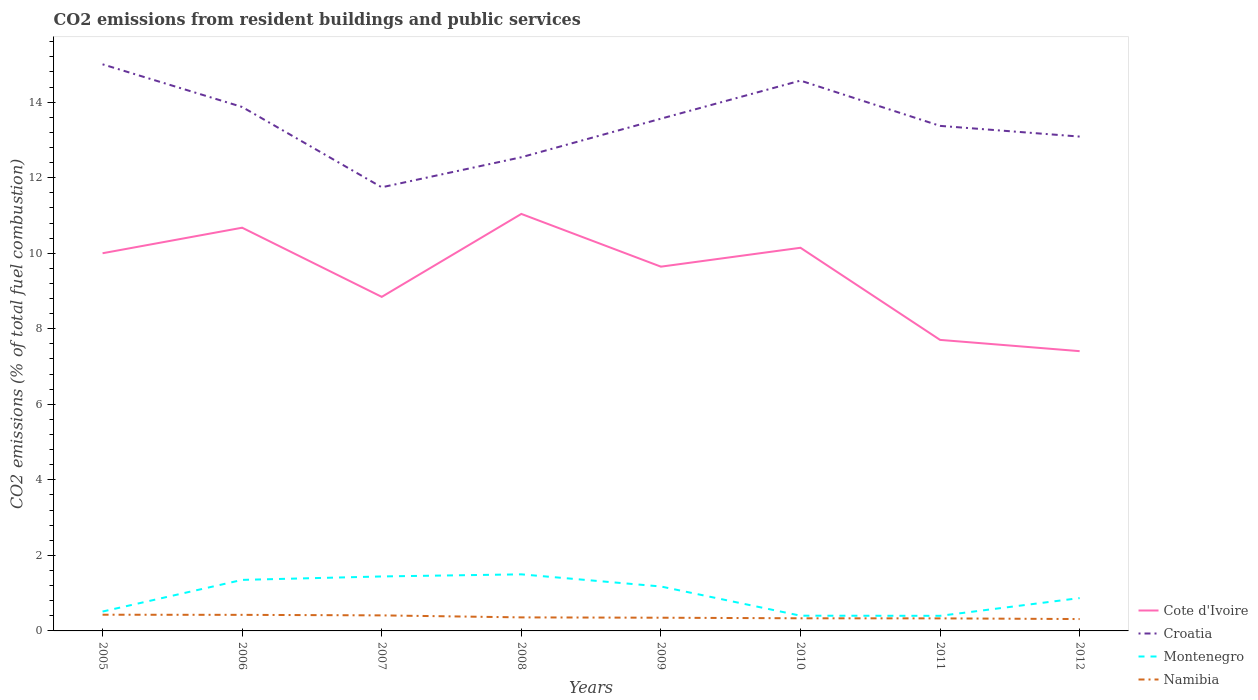Across all years, what is the maximum total CO2 emitted in Namibia?
Provide a short and direct response. 0.31. What is the total total CO2 emitted in Namibia in the graph?
Offer a very short reply. 0.08. What is the difference between the highest and the second highest total CO2 emitted in Montenegro?
Give a very brief answer. 1.1. What is the difference between the highest and the lowest total CO2 emitted in Montenegro?
Provide a short and direct response. 4. Is the total CO2 emitted in Montenegro strictly greater than the total CO2 emitted in Croatia over the years?
Make the answer very short. Yes. What is the difference between two consecutive major ticks on the Y-axis?
Your response must be concise. 2. Does the graph contain any zero values?
Give a very brief answer. No. Does the graph contain grids?
Provide a short and direct response. No. How many legend labels are there?
Keep it short and to the point. 4. How are the legend labels stacked?
Offer a terse response. Vertical. What is the title of the graph?
Provide a short and direct response. CO2 emissions from resident buildings and public services. What is the label or title of the X-axis?
Keep it short and to the point. Years. What is the label or title of the Y-axis?
Provide a short and direct response. CO2 emissions (% of total fuel combustion). What is the CO2 emissions (% of total fuel combustion) in Croatia in 2005?
Your answer should be compact. 15. What is the CO2 emissions (% of total fuel combustion) in Montenegro in 2005?
Keep it short and to the point. 0.51. What is the CO2 emissions (% of total fuel combustion) of Namibia in 2005?
Offer a very short reply. 0.43. What is the CO2 emissions (% of total fuel combustion) in Cote d'Ivoire in 2006?
Offer a terse response. 10.68. What is the CO2 emissions (% of total fuel combustion) in Croatia in 2006?
Provide a succinct answer. 13.87. What is the CO2 emissions (% of total fuel combustion) in Montenegro in 2006?
Make the answer very short. 1.35. What is the CO2 emissions (% of total fuel combustion) of Namibia in 2006?
Offer a very short reply. 0.43. What is the CO2 emissions (% of total fuel combustion) of Cote d'Ivoire in 2007?
Offer a terse response. 8.84. What is the CO2 emissions (% of total fuel combustion) in Croatia in 2007?
Provide a short and direct response. 11.75. What is the CO2 emissions (% of total fuel combustion) of Montenegro in 2007?
Give a very brief answer. 1.44. What is the CO2 emissions (% of total fuel combustion) of Namibia in 2007?
Your answer should be compact. 0.41. What is the CO2 emissions (% of total fuel combustion) of Cote d'Ivoire in 2008?
Your response must be concise. 11.04. What is the CO2 emissions (% of total fuel combustion) in Croatia in 2008?
Give a very brief answer. 12.54. What is the CO2 emissions (% of total fuel combustion) of Montenegro in 2008?
Offer a terse response. 1.5. What is the CO2 emissions (% of total fuel combustion) in Namibia in 2008?
Provide a succinct answer. 0.36. What is the CO2 emissions (% of total fuel combustion) of Cote d'Ivoire in 2009?
Keep it short and to the point. 9.64. What is the CO2 emissions (% of total fuel combustion) of Croatia in 2009?
Offer a very short reply. 13.56. What is the CO2 emissions (% of total fuel combustion) of Montenegro in 2009?
Make the answer very short. 1.18. What is the CO2 emissions (% of total fuel combustion) of Namibia in 2009?
Your response must be concise. 0.35. What is the CO2 emissions (% of total fuel combustion) of Cote d'Ivoire in 2010?
Ensure brevity in your answer.  10.14. What is the CO2 emissions (% of total fuel combustion) in Croatia in 2010?
Your response must be concise. 14.57. What is the CO2 emissions (% of total fuel combustion) of Montenegro in 2010?
Make the answer very short. 0.4. What is the CO2 emissions (% of total fuel combustion) of Namibia in 2010?
Offer a terse response. 0.33. What is the CO2 emissions (% of total fuel combustion) in Cote d'Ivoire in 2011?
Give a very brief answer. 7.71. What is the CO2 emissions (% of total fuel combustion) of Croatia in 2011?
Give a very brief answer. 13.37. What is the CO2 emissions (% of total fuel combustion) in Namibia in 2011?
Provide a short and direct response. 0.33. What is the CO2 emissions (% of total fuel combustion) of Cote d'Ivoire in 2012?
Your answer should be compact. 7.41. What is the CO2 emissions (% of total fuel combustion) in Croatia in 2012?
Provide a short and direct response. 13.09. What is the CO2 emissions (% of total fuel combustion) of Montenegro in 2012?
Offer a terse response. 0.87. What is the CO2 emissions (% of total fuel combustion) in Namibia in 2012?
Offer a very short reply. 0.31. Across all years, what is the maximum CO2 emissions (% of total fuel combustion) in Cote d'Ivoire?
Give a very brief answer. 11.04. Across all years, what is the maximum CO2 emissions (% of total fuel combustion) in Croatia?
Your answer should be very brief. 15. Across all years, what is the maximum CO2 emissions (% of total fuel combustion) in Montenegro?
Make the answer very short. 1.5. Across all years, what is the maximum CO2 emissions (% of total fuel combustion) in Namibia?
Offer a very short reply. 0.43. Across all years, what is the minimum CO2 emissions (% of total fuel combustion) of Cote d'Ivoire?
Your answer should be very brief. 7.41. Across all years, what is the minimum CO2 emissions (% of total fuel combustion) of Croatia?
Your response must be concise. 11.75. Across all years, what is the minimum CO2 emissions (% of total fuel combustion) of Montenegro?
Provide a short and direct response. 0.4. Across all years, what is the minimum CO2 emissions (% of total fuel combustion) of Namibia?
Your answer should be very brief. 0.31. What is the total CO2 emissions (% of total fuel combustion) in Cote d'Ivoire in the graph?
Keep it short and to the point. 75.46. What is the total CO2 emissions (% of total fuel combustion) of Croatia in the graph?
Your answer should be compact. 107.76. What is the total CO2 emissions (% of total fuel combustion) in Montenegro in the graph?
Keep it short and to the point. 7.65. What is the total CO2 emissions (% of total fuel combustion) of Namibia in the graph?
Make the answer very short. 2.96. What is the difference between the CO2 emissions (% of total fuel combustion) of Cote d'Ivoire in 2005 and that in 2006?
Ensure brevity in your answer.  -0.68. What is the difference between the CO2 emissions (% of total fuel combustion) in Croatia in 2005 and that in 2006?
Keep it short and to the point. 1.13. What is the difference between the CO2 emissions (% of total fuel combustion) in Montenegro in 2005 and that in 2006?
Your answer should be very brief. -0.84. What is the difference between the CO2 emissions (% of total fuel combustion) of Namibia in 2005 and that in 2006?
Your answer should be very brief. 0. What is the difference between the CO2 emissions (% of total fuel combustion) of Cote d'Ivoire in 2005 and that in 2007?
Ensure brevity in your answer.  1.16. What is the difference between the CO2 emissions (% of total fuel combustion) of Croatia in 2005 and that in 2007?
Your answer should be compact. 3.26. What is the difference between the CO2 emissions (% of total fuel combustion) in Montenegro in 2005 and that in 2007?
Offer a very short reply. -0.93. What is the difference between the CO2 emissions (% of total fuel combustion) of Namibia in 2005 and that in 2007?
Offer a very short reply. 0.02. What is the difference between the CO2 emissions (% of total fuel combustion) of Cote d'Ivoire in 2005 and that in 2008?
Offer a very short reply. -1.04. What is the difference between the CO2 emissions (% of total fuel combustion) in Croatia in 2005 and that in 2008?
Ensure brevity in your answer.  2.46. What is the difference between the CO2 emissions (% of total fuel combustion) in Montenegro in 2005 and that in 2008?
Give a very brief answer. -0.99. What is the difference between the CO2 emissions (% of total fuel combustion) of Namibia in 2005 and that in 2008?
Provide a succinct answer. 0.07. What is the difference between the CO2 emissions (% of total fuel combustion) of Cote d'Ivoire in 2005 and that in 2009?
Make the answer very short. 0.36. What is the difference between the CO2 emissions (% of total fuel combustion) in Croatia in 2005 and that in 2009?
Offer a terse response. 1.44. What is the difference between the CO2 emissions (% of total fuel combustion) in Montenegro in 2005 and that in 2009?
Your response must be concise. -0.66. What is the difference between the CO2 emissions (% of total fuel combustion) in Namibia in 2005 and that in 2009?
Provide a short and direct response. 0.08. What is the difference between the CO2 emissions (% of total fuel combustion) in Cote d'Ivoire in 2005 and that in 2010?
Offer a very short reply. -0.14. What is the difference between the CO2 emissions (% of total fuel combustion) in Croatia in 2005 and that in 2010?
Provide a succinct answer. 0.43. What is the difference between the CO2 emissions (% of total fuel combustion) of Montenegro in 2005 and that in 2010?
Keep it short and to the point. 0.11. What is the difference between the CO2 emissions (% of total fuel combustion) of Namibia in 2005 and that in 2010?
Your response must be concise. 0.09. What is the difference between the CO2 emissions (% of total fuel combustion) of Cote d'Ivoire in 2005 and that in 2011?
Keep it short and to the point. 2.29. What is the difference between the CO2 emissions (% of total fuel combustion) in Croatia in 2005 and that in 2011?
Make the answer very short. 1.63. What is the difference between the CO2 emissions (% of total fuel combustion) in Montenegro in 2005 and that in 2011?
Offer a very short reply. 0.11. What is the difference between the CO2 emissions (% of total fuel combustion) of Namibia in 2005 and that in 2011?
Offer a terse response. 0.1. What is the difference between the CO2 emissions (% of total fuel combustion) in Cote d'Ivoire in 2005 and that in 2012?
Provide a succinct answer. 2.59. What is the difference between the CO2 emissions (% of total fuel combustion) in Croatia in 2005 and that in 2012?
Your answer should be compact. 1.91. What is the difference between the CO2 emissions (% of total fuel combustion) of Montenegro in 2005 and that in 2012?
Provide a short and direct response. -0.36. What is the difference between the CO2 emissions (% of total fuel combustion) in Namibia in 2005 and that in 2012?
Your answer should be very brief. 0.11. What is the difference between the CO2 emissions (% of total fuel combustion) of Cote d'Ivoire in 2006 and that in 2007?
Give a very brief answer. 1.83. What is the difference between the CO2 emissions (% of total fuel combustion) of Croatia in 2006 and that in 2007?
Ensure brevity in your answer.  2.13. What is the difference between the CO2 emissions (% of total fuel combustion) in Montenegro in 2006 and that in 2007?
Your answer should be compact. -0.09. What is the difference between the CO2 emissions (% of total fuel combustion) of Namibia in 2006 and that in 2007?
Make the answer very short. 0.01. What is the difference between the CO2 emissions (% of total fuel combustion) in Cote d'Ivoire in 2006 and that in 2008?
Give a very brief answer. -0.36. What is the difference between the CO2 emissions (% of total fuel combustion) of Croatia in 2006 and that in 2008?
Provide a succinct answer. 1.33. What is the difference between the CO2 emissions (% of total fuel combustion) of Montenegro in 2006 and that in 2008?
Your answer should be compact. -0.15. What is the difference between the CO2 emissions (% of total fuel combustion) of Namibia in 2006 and that in 2008?
Your answer should be very brief. 0.07. What is the difference between the CO2 emissions (% of total fuel combustion) of Cote d'Ivoire in 2006 and that in 2009?
Offer a very short reply. 1.03. What is the difference between the CO2 emissions (% of total fuel combustion) of Croatia in 2006 and that in 2009?
Your answer should be very brief. 0.31. What is the difference between the CO2 emissions (% of total fuel combustion) of Montenegro in 2006 and that in 2009?
Make the answer very short. 0.17. What is the difference between the CO2 emissions (% of total fuel combustion) in Namibia in 2006 and that in 2009?
Your response must be concise. 0.08. What is the difference between the CO2 emissions (% of total fuel combustion) in Cote d'Ivoire in 2006 and that in 2010?
Your answer should be compact. 0.53. What is the difference between the CO2 emissions (% of total fuel combustion) of Croatia in 2006 and that in 2010?
Your response must be concise. -0.7. What is the difference between the CO2 emissions (% of total fuel combustion) in Montenegro in 2006 and that in 2010?
Offer a terse response. 0.95. What is the difference between the CO2 emissions (% of total fuel combustion) in Namibia in 2006 and that in 2010?
Your response must be concise. 0.09. What is the difference between the CO2 emissions (% of total fuel combustion) in Cote d'Ivoire in 2006 and that in 2011?
Your answer should be compact. 2.97. What is the difference between the CO2 emissions (% of total fuel combustion) in Croatia in 2006 and that in 2011?
Your answer should be very brief. 0.5. What is the difference between the CO2 emissions (% of total fuel combustion) of Montenegro in 2006 and that in 2011?
Ensure brevity in your answer.  0.95. What is the difference between the CO2 emissions (% of total fuel combustion) in Namibia in 2006 and that in 2011?
Provide a succinct answer. 0.09. What is the difference between the CO2 emissions (% of total fuel combustion) in Cote d'Ivoire in 2006 and that in 2012?
Provide a short and direct response. 3.27. What is the difference between the CO2 emissions (% of total fuel combustion) in Croatia in 2006 and that in 2012?
Provide a succinct answer. 0.78. What is the difference between the CO2 emissions (% of total fuel combustion) in Montenegro in 2006 and that in 2012?
Offer a very short reply. 0.48. What is the difference between the CO2 emissions (% of total fuel combustion) of Cote d'Ivoire in 2007 and that in 2008?
Your answer should be very brief. -2.2. What is the difference between the CO2 emissions (% of total fuel combustion) of Croatia in 2007 and that in 2008?
Offer a very short reply. -0.8. What is the difference between the CO2 emissions (% of total fuel combustion) in Montenegro in 2007 and that in 2008?
Your response must be concise. -0.06. What is the difference between the CO2 emissions (% of total fuel combustion) in Namibia in 2007 and that in 2008?
Your answer should be compact. 0.05. What is the difference between the CO2 emissions (% of total fuel combustion) of Cote d'Ivoire in 2007 and that in 2009?
Make the answer very short. -0.8. What is the difference between the CO2 emissions (% of total fuel combustion) in Croatia in 2007 and that in 2009?
Offer a terse response. -1.82. What is the difference between the CO2 emissions (% of total fuel combustion) of Montenegro in 2007 and that in 2009?
Your response must be concise. 0.27. What is the difference between the CO2 emissions (% of total fuel combustion) in Namibia in 2007 and that in 2009?
Offer a terse response. 0.06. What is the difference between the CO2 emissions (% of total fuel combustion) of Cote d'Ivoire in 2007 and that in 2010?
Keep it short and to the point. -1.3. What is the difference between the CO2 emissions (% of total fuel combustion) of Croatia in 2007 and that in 2010?
Keep it short and to the point. -2.83. What is the difference between the CO2 emissions (% of total fuel combustion) in Montenegro in 2007 and that in 2010?
Offer a very short reply. 1.04. What is the difference between the CO2 emissions (% of total fuel combustion) of Namibia in 2007 and that in 2010?
Your answer should be very brief. 0.08. What is the difference between the CO2 emissions (% of total fuel combustion) of Cote d'Ivoire in 2007 and that in 2011?
Your answer should be very brief. 1.14. What is the difference between the CO2 emissions (% of total fuel combustion) of Croatia in 2007 and that in 2011?
Give a very brief answer. -1.63. What is the difference between the CO2 emissions (% of total fuel combustion) in Montenegro in 2007 and that in 2011?
Give a very brief answer. 1.04. What is the difference between the CO2 emissions (% of total fuel combustion) in Namibia in 2007 and that in 2011?
Keep it short and to the point. 0.08. What is the difference between the CO2 emissions (% of total fuel combustion) of Cote d'Ivoire in 2007 and that in 2012?
Provide a short and direct response. 1.44. What is the difference between the CO2 emissions (% of total fuel combustion) of Croatia in 2007 and that in 2012?
Offer a very short reply. -1.34. What is the difference between the CO2 emissions (% of total fuel combustion) in Montenegro in 2007 and that in 2012?
Make the answer very short. 0.57. What is the difference between the CO2 emissions (% of total fuel combustion) in Namibia in 2007 and that in 2012?
Ensure brevity in your answer.  0.1. What is the difference between the CO2 emissions (% of total fuel combustion) in Cote d'Ivoire in 2008 and that in 2009?
Provide a succinct answer. 1.4. What is the difference between the CO2 emissions (% of total fuel combustion) in Croatia in 2008 and that in 2009?
Give a very brief answer. -1.02. What is the difference between the CO2 emissions (% of total fuel combustion) of Montenegro in 2008 and that in 2009?
Provide a short and direct response. 0.32. What is the difference between the CO2 emissions (% of total fuel combustion) of Namibia in 2008 and that in 2009?
Provide a short and direct response. 0.01. What is the difference between the CO2 emissions (% of total fuel combustion) in Cote d'Ivoire in 2008 and that in 2010?
Your answer should be very brief. 0.9. What is the difference between the CO2 emissions (% of total fuel combustion) of Croatia in 2008 and that in 2010?
Provide a succinct answer. -2.03. What is the difference between the CO2 emissions (% of total fuel combustion) of Montenegro in 2008 and that in 2010?
Make the answer very short. 1.09. What is the difference between the CO2 emissions (% of total fuel combustion) of Namibia in 2008 and that in 2010?
Offer a very short reply. 0.02. What is the difference between the CO2 emissions (% of total fuel combustion) of Cote d'Ivoire in 2008 and that in 2011?
Provide a succinct answer. 3.34. What is the difference between the CO2 emissions (% of total fuel combustion) of Croatia in 2008 and that in 2011?
Provide a succinct answer. -0.83. What is the difference between the CO2 emissions (% of total fuel combustion) in Montenegro in 2008 and that in 2011?
Make the answer very short. 1.1. What is the difference between the CO2 emissions (% of total fuel combustion) in Namibia in 2008 and that in 2011?
Offer a very short reply. 0.03. What is the difference between the CO2 emissions (% of total fuel combustion) in Cote d'Ivoire in 2008 and that in 2012?
Your response must be concise. 3.63. What is the difference between the CO2 emissions (% of total fuel combustion) of Croatia in 2008 and that in 2012?
Ensure brevity in your answer.  -0.55. What is the difference between the CO2 emissions (% of total fuel combustion) in Montenegro in 2008 and that in 2012?
Offer a terse response. 0.63. What is the difference between the CO2 emissions (% of total fuel combustion) of Namibia in 2008 and that in 2012?
Give a very brief answer. 0.04. What is the difference between the CO2 emissions (% of total fuel combustion) of Cote d'Ivoire in 2009 and that in 2010?
Make the answer very short. -0.5. What is the difference between the CO2 emissions (% of total fuel combustion) of Croatia in 2009 and that in 2010?
Keep it short and to the point. -1.01. What is the difference between the CO2 emissions (% of total fuel combustion) in Montenegro in 2009 and that in 2010?
Give a very brief answer. 0.77. What is the difference between the CO2 emissions (% of total fuel combustion) in Namibia in 2009 and that in 2010?
Provide a short and direct response. 0.02. What is the difference between the CO2 emissions (% of total fuel combustion) in Cote d'Ivoire in 2009 and that in 2011?
Offer a very short reply. 1.94. What is the difference between the CO2 emissions (% of total fuel combustion) in Croatia in 2009 and that in 2011?
Provide a succinct answer. 0.19. What is the difference between the CO2 emissions (% of total fuel combustion) of Montenegro in 2009 and that in 2011?
Give a very brief answer. 0.78. What is the difference between the CO2 emissions (% of total fuel combustion) in Namibia in 2009 and that in 2011?
Provide a short and direct response. 0.02. What is the difference between the CO2 emissions (% of total fuel combustion) in Cote d'Ivoire in 2009 and that in 2012?
Offer a very short reply. 2.24. What is the difference between the CO2 emissions (% of total fuel combustion) of Croatia in 2009 and that in 2012?
Give a very brief answer. 0.47. What is the difference between the CO2 emissions (% of total fuel combustion) of Montenegro in 2009 and that in 2012?
Your response must be concise. 0.31. What is the difference between the CO2 emissions (% of total fuel combustion) of Namibia in 2009 and that in 2012?
Offer a terse response. 0.04. What is the difference between the CO2 emissions (% of total fuel combustion) of Cote d'Ivoire in 2010 and that in 2011?
Offer a terse response. 2.44. What is the difference between the CO2 emissions (% of total fuel combustion) in Croatia in 2010 and that in 2011?
Provide a short and direct response. 1.2. What is the difference between the CO2 emissions (% of total fuel combustion) in Montenegro in 2010 and that in 2011?
Make the answer very short. 0. What is the difference between the CO2 emissions (% of total fuel combustion) in Namibia in 2010 and that in 2011?
Give a very brief answer. 0. What is the difference between the CO2 emissions (% of total fuel combustion) of Cote d'Ivoire in 2010 and that in 2012?
Your answer should be compact. 2.74. What is the difference between the CO2 emissions (% of total fuel combustion) in Croatia in 2010 and that in 2012?
Provide a succinct answer. 1.48. What is the difference between the CO2 emissions (% of total fuel combustion) in Montenegro in 2010 and that in 2012?
Make the answer very short. -0.47. What is the difference between the CO2 emissions (% of total fuel combustion) in Cote d'Ivoire in 2011 and that in 2012?
Your answer should be very brief. 0.3. What is the difference between the CO2 emissions (% of total fuel combustion) in Croatia in 2011 and that in 2012?
Keep it short and to the point. 0.28. What is the difference between the CO2 emissions (% of total fuel combustion) in Montenegro in 2011 and that in 2012?
Make the answer very short. -0.47. What is the difference between the CO2 emissions (% of total fuel combustion) in Namibia in 2011 and that in 2012?
Provide a succinct answer. 0.02. What is the difference between the CO2 emissions (% of total fuel combustion) of Cote d'Ivoire in 2005 and the CO2 emissions (% of total fuel combustion) of Croatia in 2006?
Your answer should be compact. -3.87. What is the difference between the CO2 emissions (% of total fuel combustion) in Cote d'Ivoire in 2005 and the CO2 emissions (% of total fuel combustion) in Montenegro in 2006?
Make the answer very short. 8.65. What is the difference between the CO2 emissions (% of total fuel combustion) in Cote d'Ivoire in 2005 and the CO2 emissions (% of total fuel combustion) in Namibia in 2006?
Keep it short and to the point. 9.57. What is the difference between the CO2 emissions (% of total fuel combustion) of Croatia in 2005 and the CO2 emissions (% of total fuel combustion) of Montenegro in 2006?
Offer a very short reply. 13.65. What is the difference between the CO2 emissions (% of total fuel combustion) in Croatia in 2005 and the CO2 emissions (% of total fuel combustion) in Namibia in 2006?
Ensure brevity in your answer.  14.58. What is the difference between the CO2 emissions (% of total fuel combustion) of Montenegro in 2005 and the CO2 emissions (% of total fuel combustion) of Namibia in 2006?
Keep it short and to the point. 0.09. What is the difference between the CO2 emissions (% of total fuel combustion) in Cote d'Ivoire in 2005 and the CO2 emissions (% of total fuel combustion) in Croatia in 2007?
Offer a terse response. -1.75. What is the difference between the CO2 emissions (% of total fuel combustion) of Cote d'Ivoire in 2005 and the CO2 emissions (% of total fuel combustion) of Montenegro in 2007?
Provide a succinct answer. 8.56. What is the difference between the CO2 emissions (% of total fuel combustion) in Cote d'Ivoire in 2005 and the CO2 emissions (% of total fuel combustion) in Namibia in 2007?
Your response must be concise. 9.59. What is the difference between the CO2 emissions (% of total fuel combustion) in Croatia in 2005 and the CO2 emissions (% of total fuel combustion) in Montenegro in 2007?
Offer a very short reply. 13.56. What is the difference between the CO2 emissions (% of total fuel combustion) in Croatia in 2005 and the CO2 emissions (% of total fuel combustion) in Namibia in 2007?
Your response must be concise. 14.59. What is the difference between the CO2 emissions (% of total fuel combustion) of Montenegro in 2005 and the CO2 emissions (% of total fuel combustion) of Namibia in 2007?
Ensure brevity in your answer.  0.1. What is the difference between the CO2 emissions (% of total fuel combustion) of Cote d'Ivoire in 2005 and the CO2 emissions (% of total fuel combustion) of Croatia in 2008?
Offer a very short reply. -2.54. What is the difference between the CO2 emissions (% of total fuel combustion) of Cote d'Ivoire in 2005 and the CO2 emissions (% of total fuel combustion) of Montenegro in 2008?
Offer a terse response. 8.5. What is the difference between the CO2 emissions (% of total fuel combustion) in Cote d'Ivoire in 2005 and the CO2 emissions (% of total fuel combustion) in Namibia in 2008?
Offer a very short reply. 9.64. What is the difference between the CO2 emissions (% of total fuel combustion) of Croatia in 2005 and the CO2 emissions (% of total fuel combustion) of Montenegro in 2008?
Keep it short and to the point. 13.5. What is the difference between the CO2 emissions (% of total fuel combustion) in Croatia in 2005 and the CO2 emissions (% of total fuel combustion) in Namibia in 2008?
Your answer should be compact. 14.64. What is the difference between the CO2 emissions (% of total fuel combustion) of Montenegro in 2005 and the CO2 emissions (% of total fuel combustion) of Namibia in 2008?
Offer a terse response. 0.15. What is the difference between the CO2 emissions (% of total fuel combustion) in Cote d'Ivoire in 2005 and the CO2 emissions (% of total fuel combustion) in Croatia in 2009?
Provide a short and direct response. -3.56. What is the difference between the CO2 emissions (% of total fuel combustion) in Cote d'Ivoire in 2005 and the CO2 emissions (% of total fuel combustion) in Montenegro in 2009?
Provide a short and direct response. 8.82. What is the difference between the CO2 emissions (% of total fuel combustion) in Cote d'Ivoire in 2005 and the CO2 emissions (% of total fuel combustion) in Namibia in 2009?
Give a very brief answer. 9.65. What is the difference between the CO2 emissions (% of total fuel combustion) in Croatia in 2005 and the CO2 emissions (% of total fuel combustion) in Montenegro in 2009?
Provide a short and direct response. 13.83. What is the difference between the CO2 emissions (% of total fuel combustion) of Croatia in 2005 and the CO2 emissions (% of total fuel combustion) of Namibia in 2009?
Keep it short and to the point. 14.65. What is the difference between the CO2 emissions (% of total fuel combustion) in Montenegro in 2005 and the CO2 emissions (% of total fuel combustion) in Namibia in 2009?
Keep it short and to the point. 0.16. What is the difference between the CO2 emissions (% of total fuel combustion) of Cote d'Ivoire in 2005 and the CO2 emissions (% of total fuel combustion) of Croatia in 2010?
Offer a terse response. -4.57. What is the difference between the CO2 emissions (% of total fuel combustion) of Cote d'Ivoire in 2005 and the CO2 emissions (% of total fuel combustion) of Montenegro in 2010?
Your response must be concise. 9.6. What is the difference between the CO2 emissions (% of total fuel combustion) in Cote d'Ivoire in 2005 and the CO2 emissions (% of total fuel combustion) in Namibia in 2010?
Provide a succinct answer. 9.67. What is the difference between the CO2 emissions (% of total fuel combustion) of Croatia in 2005 and the CO2 emissions (% of total fuel combustion) of Montenegro in 2010?
Give a very brief answer. 14.6. What is the difference between the CO2 emissions (% of total fuel combustion) of Croatia in 2005 and the CO2 emissions (% of total fuel combustion) of Namibia in 2010?
Offer a very short reply. 14.67. What is the difference between the CO2 emissions (% of total fuel combustion) in Montenegro in 2005 and the CO2 emissions (% of total fuel combustion) in Namibia in 2010?
Provide a succinct answer. 0.18. What is the difference between the CO2 emissions (% of total fuel combustion) of Cote d'Ivoire in 2005 and the CO2 emissions (% of total fuel combustion) of Croatia in 2011?
Your answer should be compact. -3.37. What is the difference between the CO2 emissions (% of total fuel combustion) of Cote d'Ivoire in 2005 and the CO2 emissions (% of total fuel combustion) of Namibia in 2011?
Make the answer very short. 9.67. What is the difference between the CO2 emissions (% of total fuel combustion) of Croatia in 2005 and the CO2 emissions (% of total fuel combustion) of Montenegro in 2011?
Your answer should be very brief. 14.6. What is the difference between the CO2 emissions (% of total fuel combustion) of Croatia in 2005 and the CO2 emissions (% of total fuel combustion) of Namibia in 2011?
Offer a terse response. 14.67. What is the difference between the CO2 emissions (% of total fuel combustion) of Montenegro in 2005 and the CO2 emissions (% of total fuel combustion) of Namibia in 2011?
Give a very brief answer. 0.18. What is the difference between the CO2 emissions (% of total fuel combustion) in Cote d'Ivoire in 2005 and the CO2 emissions (% of total fuel combustion) in Croatia in 2012?
Provide a succinct answer. -3.09. What is the difference between the CO2 emissions (% of total fuel combustion) of Cote d'Ivoire in 2005 and the CO2 emissions (% of total fuel combustion) of Montenegro in 2012?
Your answer should be very brief. 9.13. What is the difference between the CO2 emissions (% of total fuel combustion) of Cote d'Ivoire in 2005 and the CO2 emissions (% of total fuel combustion) of Namibia in 2012?
Give a very brief answer. 9.69. What is the difference between the CO2 emissions (% of total fuel combustion) of Croatia in 2005 and the CO2 emissions (% of total fuel combustion) of Montenegro in 2012?
Provide a short and direct response. 14.13. What is the difference between the CO2 emissions (% of total fuel combustion) in Croatia in 2005 and the CO2 emissions (% of total fuel combustion) in Namibia in 2012?
Provide a short and direct response. 14.69. What is the difference between the CO2 emissions (% of total fuel combustion) of Montenegro in 2005 and the CO2 emissions (% of total fuel combustion) of Namibia in 2012?
Your answer should be compact. 0.2. What is the difference between the CO2 emissions (% of total fuel combustion) in Cote d'Ivoire in 2006 and the CO2 emissions (% of total fuel combustion) in Croatia in 2007?
Provide a short and direct response. -1.07. What is the difference between the CO2 emissions (% of total fuel combustion) of Cote d'Ivoire in 2006 and the CO2 emissions (% of total fuel combustion) of Montenegro in 2007?
Your answer should be very brief. 9.23. What is the difference between the CO2 emissions (% of total fuel combustion) in Cote d'Ivoire in 2006 and the CO2 emissions (% of total fuel combustion) in Namibia in 2007?
Keep it short and to the point. 10.26. What is the difference between the CO2 emissions (% of total fuel combustion) of Croatia in 2006 and the CO2 emissions (% of total fuel combustion) of Montenegro in 2007?
Make the answer very short. 12.43. What is the difference between the CO2 emissions (% of total fuel combustion) of Croatia in 2006 and the CO2 emissions (% of total fuel combustion) of Namibia in 2007?
Keep it short and to the point. 13.46. What is the difference between the CO2 emissions (% of total fuel combustion) of Montenegro in 2006 and the CO2 emissions (% of total fuel combustion) of Namibia in 2007?
Offer a terse response. 0.94. What is the difference between the CO2 emissions (% of total fuel combustion) of Cote d'Ivoire in 2006 and the CO2 emissions (% of total fuel combustion) of Croatia in 2008?
Offer a very short reply. -1.87. What is the difference between the CO2 emissions (% of total fuel combustion) in Cote d'Ivoire in 2006 and the CO2 emissions (% of total fuel combustion) in Montenegro in 2008?
Ensure brevity in your answer.  9.18. What is the difference between the CO2 emissions (% of total fuel combustion) of Cote d'Ivoire in 2006 and the CO2 emissions (% of total fuel combustion) of Namibia in 2008?
Offer a very short reply. 10.32. What is the difference between the CO2 emissions (% of total fuel combustion) in Croatia in 2006 and the CO2 emissions (% of total fuel combustion) in Montenegro in 2008?
Ensure brevity in your answer.  12.37. What is the difference between the CO2 emissions (% of total fuel combustion) of Croatia in 2006 and the CO2 emissions (% of total fuel combustion) of Namibia in 2008?
Make the answer very short. 13.51. What is the difference between the CO2 emissions (% of total fuel combustion) of Cote d'Ivoire in 2006 and the CO2 emissions (% of total fuel combustion) of Croatia in 2009?
Offer a very short reply. -2.89. What is the difference between the CO2 emissions (% of total fuel combustion) of Cote d'Ivoire in 2006 and the CO2 emissions (% of total fuel combustion) of Montenegro in 2009?
Offer a very short reply. 9.5. What is the difference between the CO2 emissions (% of total fuel combustion) in Cote d'Ivoire in 2006 and the CO2 emissions (% of total fuel combustion) in Namibia in 2009?
Provide a succinct answer. 10.33. What is the difference between the CO2 emissions (% of total fuel combustion) in Croatia in 2006 and the CO2 emissions (% of total fuel combustion) in Montenegro in 2009?
Your response must be concise. 12.7. What is the difference between the CO2 emissions (% of total fuel combustion) of Croatia in 2006 and the CO2 emissions (% of total fuel combustion) of Namibia in 2009?
Offer a terse response. 13.52. What is the difference between the CO2 emissions (% of total fuel combustion) in Cote d'Ivoire in 2006 and the CO2 emissions (% of total fuel combustion) in Croatia in 2010?
Ensure brevity in your answer.  -3.9. What is the difference between the CO2 emissions (% of total fuel combustion) of Cote d'Ivoire in 2006 and the CO2 emissions (% of total fuel combustion) of Montenegro in 2010?
Offer a very short reply. 10.27. What is the difference between the CO2 emissions (% of total fuel combustion) in Cote d'Ivoire in 2006 and the CO2 emissions (% of total fuel combustion) in Namibia in 2010?
Offer a terse response. 10.34. What is the difference between the CO2 emissions (% of total fuel combustion) of Croatia in 2006 and the CO2 emissions (% of total fuel combustion) of Montenegro in 2010?
Provide a short and direct response. 13.47. What is the difference between the CO2 emissions (% of total fuel combustion) in Croatia in 2006 and the CO2 emissions (% of total fuel combustion) in Namibia in 2010?
Your answer should be very brief. 13.54. What is the difference between the CO2 emissions (% of total fuel combustion) in Montenegro in 2006 and the CO2 emissions (% of total fuel combustion) in Namibia in 2010?
Your answer should be very brief. 1.02. What is the difference between the CO2 emissions (% of total fuel combustion) in Cote d'Ivoire in 2006 and the CO2 emissions (% of total fuel combustion) in Croatia in 2011?
Your answer should be very brief. -2.7. What is the difference between the CO2 emissions (% of total fuel combustion) in Cote d'Ivoire in 2006 and the CO2 emissions (% of total fuel combustion) in Montenegro in 2011?
Offer a terse response. 10.28. What is the difference between the CO2 emissions (% of total fuel combustion) in Cote d'Ivoire in 2006 and the CO2 emissions (% of total fuel combustion) in Namibia in 2011?
Your answer should be very brief. 10.34. What is the difference between the CO2 emissions (% of total fuel combustion) of Croatia in 2006 and the CO2 emissions (% of total fuel combustion) of Montenegro in 2011?
Your answer should be very brief. 13.47. What is the difference between the CO2 emissions (% of total fuel combustion) of Croatia in 2006 and the CO2 emissions (% of total fuel combustion) of Namibia in 2011?
Your answer should be very brief. 13.54. What is the difference between the CO2 emissions (% of total fuel combustion) of Montenegro in 2006 and the CO2 emissions (% of total fuel combustion) of Namibia in 2011?
Provide a short and direct response. 1.02. What is the difference between the CO2 emissions (% of total fuel combustion) of Cote d'Ivoire in 2006 and the CO2 emissions (% of total fuel combustion) of Croatia in 2012?
Ensure brevity in your answer.  -2.41. What is the difference between the CO2 emissions (% of total fuel combustion) of Cote d'Ivoire in 2006 and the CO2 emissions (% of total fuel combustion) of Montenegro in 2012?
Make the answer very short. 9.81. What is the difference between the CO2 emissions (% of total fuel combustion) in Cote d'Ivoire in 2006 and the CO2 emissions (% of total fuel combustion) in Namibia in 2012?
Give a very brief answer. 10.36. What is the difference between the CO2 emissions (% of total fuel combustion) of Croatia in 2006 and the CO2 emissions (% of total fuel combustion) of Montenegro in 2012?
Give a very brief answer. 13. What is the difference between the CO2 emissions (% of total fuel combustion) of Croatia in 2006 and the CO2 emissions (% of total fuel combustion) of Namibia in 2012?
Make the answer very short. 13.56. What is the difference between the CO2 emissions (% of total fuel combustion) in Montenegro in 2006 and the CO2 emissions (% of total fuel combustion) in Namibia in 2012?
Provide a succinct answer. 1.04. What is the difference between the CO2 emissions (% of total fuel combustion) in Cote d'Ivoire in 2007 and the CO2 emissions (% of total fuel combustion) in Croatia in 2008?
Keep it short and to the point. -3.7. What is the difference between the CO2 emissions (% of total fuel combustion) of Cote d'Ivoire in 2007 and the CO2 emissions (% of total fuel combustion) of Montenegro in 2008?
Your answer should be compact. 7.35. What is the difference between the CO2 emissions (% of total fuel combustion) in Cote d'Ivoire in 2007 and the CO2 emissions (% of total fuel combustion) in Namibia in 2008?
Your answer should be compact. 8.49. What is the difference between the CO2 emissions (% of total fuel combustion) in Croatia in 2007 and the CO2 emissions (% of total fuel combustion) in Montenegro in 2008?
Ensure brevity in your answer.  10.25. What is the difference between the CO2 emissions (% of total fuel combustion) of Croatia in 2007 and the CO2 emissions (% of total fuel combustion) of Namibia in 2008?
Offer a terse response. 11.39. What is the difference between the CO2 emissions (% of total fuel combustion) in Montenegro in 2007 and the CO2 emissions (% of total fuel combustion) in Namibia in 2008?
Your answer should be very brief. 1.08. What is the difference between the CO2 emissions (% of total fuel combustion) in Cote d'Ivoire in 2007 and the CO2 emissions (% of total fuel combustion) in Croatia in 2009?
Give a very brief answer. -4.72. What is the difference between the CO2 emissions (% of total fuel combustion) of Cote d'Ivoire in 2007 and the CO2 emissions (% of total fuel combustion) of Montenegro in 2009?
Make the answer very short. 7.67. What is the difference between the CO2 emissions (% of total fuel combustion) of Cote d'Ivoire in 2007 and the CO2 emissions (% of total fuel combustion) of Namibia in 2009?
Ensure brevity in your answer.  8.5. What is the difference between the CO2 emissions (% of total fuel combustion) of Croatia in 2007 and the CO2 emissions (% of total fuel combustion) of Montenegro in 2009?
Offer a very short reply. 10.57. What is the difference between the CO2 emissions (% of total fuel combustion) in Croatia in 2007 and the CO2 emissions (% of total fuel combustion) in Namibia in 2009?
Ensure brevity in your answer.  11.4. What is the difference between the CO2 emissions (% of total fuel combustion) in Montenegro in 2007 and the CO2 emissions (% of total fuel combustion) in Namibia in 2009?
Your answer should be compact. 1.09. What is the difference between the CO2 emissions (% of total fuel combustion) in Cote d'Ivoire in 2007 and the CO2 emissions (% of total fuel combustion) in Croatia in 2010?
Your response must be concise. -5.73. What is the difference between the CO2 emissions (% of total fuel combustion) of Cote d'Ivoire in 2007 and the CO2 emissions (% of total fuel combustion) of Montenegro in 2010?
Keep it short and to the point. 8.44. What is the difference between the CO2 emissions (% of total fuel combustion) of Cote d'Ivoire in 2007 and the CO2 emissions (% of total fuel combustion) of Namibia in 2010?
Provide a short and direct response. 8.51. What is the difference between the CO2 emissions (% of total fuel combustion) of Croatia in 2007 and the CO2 emissions (% of total fuel combustion) of Montenegro in 2010?
Your answer should be very brief. 11.34. What is the difference between the CO2 emissions (% of total fuel combustion) of Croatia in 2007 and the CO2 emissions (% of total fuel combustion) of Namibia in 2010?
Provide a short and direct response. 11.41. What is the difference between the CO2 emissions (% of total fuel combustion) in Montenegro in 2007 and the CO2 emissions (% of total fuel combustion) in Namibia in 2010?
Offer a very short reply. 1.11. What is the difference between the CO2 emissions (% of total fuel combustion) in Cote d'Ivoire in 2007 and the CO2 emissions (% of total fuel combustion) in Croatia in 2011?
Keep it short and to the point. -4.53. What is the difference between the CO2 emissions (% of total fuel combustion) in Cote d'Ivoire in 2007 and the CO2 emissions (% of total fuel combustion) in Montenegro in 2011?
Offer a very short reply. 8.44. What is the difference between the CO2 emissions (% of total fuel combustion) of Cote d'Ivoire in 2007 and the CO2 emissions (% of total fuel combustion) of Namibia in 2011?
Ensure brevity in your answer.  8.51. What is the difference between the CO2 emissions (% of total fuel combustion) of Croatia in 2007 and the CO2 emissions (% of total fuel combustion) of Montenegro in 2011?
Make the answer very short. 11.35. What is the difference between the CO2 emissions (% of total fuel combustion) of Croatia in 2007 and the CO2 emissions (% of total fuel combustion) of Namibia in 2011?
Your answer should be very brief. 11.41. What is the difference between the CO2 emissions (% of total fuel combustion) in Montenegro in 2007 and the CO2 emissions (% of total fuel combustion) in Namibia in 2011?
Offer a terse response. 1.11. What is the difference between the CO2 emissions (% of total fuel combustion) in Cote d'Ivoire in 2007 and the CO2 emissions (% of total fuel combustion) in Croatia in 2012?
Make the answer very short. -4.24. What is the difference between the CO2 emissions (% of total fuel combustion) of Cote d'Ivoire in 2007 and the CO2 emissions (% of total fuel combustion) of Montenegro in 2012?
Your answer should be very brief. 7.98. What is the difference between the CO2 emissions (% of total fuel combustion) of Cote d'Ivoire in 2007 and the CO2 emissions (% of total fuel combustion) of Namibia in 2012?
Make the answer very short. 8.53. What is the difference between the CO2 emissions (% of total fuel combustion) of Croatia in 2007 and the CO2 emissions (% of total fuel combustion) of Montenegro in 2012?
Provide a short and direct response. 10.88. What is the difference between the CO2 emissions (% of total fuel combustion) in Croatia in 2007 and the CO2 emissions (% of total fuel combustion) in Namibia in 2012?
Keep it short and to the point. 11.43. What is the difference between the CO2 emissions (% of total fuel combustion) in Montenegro in 2007 and the CO2 emissions (% of total fuel combustion) in Namibia in 2012?
Ensure brevity in your answer.  1.13. What is the difference between the CO2 emissions (% of total fuel combustion) in Cote d'Ivoire in 2008 and the CO2 emissions (% of total fuel combustion) in Croatia in 2009?
Give a very brief answer. -2.52. What is the difference between the CO2 emissions (% of total fuel combustion) of Cote d'Ivoire in 2008 and the CO2 emissions (% of total fuel combustion) of Montenegro in 2009?
Your answer should be very brief. 9.86. What is the difference between the CO2 emissions (% of total fuel combustion) in Cote d'Ivoire in 2008 and the CO2 emissions (% of total fuel combustion) in Namibia in 2009?
Offer a terse response. 10.69. What is the difference between the CO2 emissions (% of total fuel combustion) of Croatia in 2008 and the CO2 emissions (% of total fuel combustion) of Montenegro in 2009?
Your answer should be compact. 11.37. What is the difference between the CO2 emissions (% of total fuel combustion) in Croatia in 2008 and the CO2 emissions (% of total fuel combustion) in Namibia in 2009?
Your response must be concise. 12.19. What is the difference between the CO2 emissions (% of total fuel combustion) of Montenegro in 2008 and the CO2 emissions (% of total fuel combustion) of Namibia in 2009?
Make the answer very short. 1.15. What is the difference between the CO2 emissions (% of total fuel combustion) in Cote d'Ivoire in 2008 and the CO2 emissions (% of total fuel combustion) in Croatia in 2010?
Provide a short and direct response. -3.53. What is the difference between the CO2 emissions (% of total fuel combustion) of Cote d'Ivoire in 2008 and the CO2 emissions (% of total fuel combustion) of Montenegro in 2010?
Offer a very short reply. 10.64. What is the difference between the CO2 emissions (% of total fuel combustion) of Cote d'Ivoire in 2008 and the CO2 emissions (% of total fuel combustion) of Namibia in 2010?
Offer a terse response. 10.71. What is the difference between the CO2 emissions (% of total fuel combustion) in Croatia in 2008 and the CO2 emissions (% of total fuel combustion) in Montenegro in 2010?
Provide a succinct answer. 12.14. What is the difference between the CO2 emissions (% of total fuel combustion) in Croatia in 2008 and the CO2 emissions (% of total fuel combustion) in Namibia in 2010?
Make the answer very short. 12.21. What is the difference between the CO2 emissions (% of total fuel combustion) of Montenegro in 2008 and the CO2 emissions (% of total fuel combustion) of Namibia in 2010?
Provide a short and direct response. 1.16. What is the difference between the CO2 emissions (% of total fuel combustion) in Cote d'Ivoire in 2008 and the CO2 emissions (% of total fuel combustion) in Croatia in 2011?
Keep it short and to the point. -2.33. What is the difference between the CO2 emissions (% of total fuel combustion) in Cote d'Ivoire in 2008 and the CO2 emissions (% of total fuel combustion) in Montenegro in 2011?
Give a very brief answer. 10.64. What is the difference between the CO2 emissions (% of total fuel combustion) in Cote d'Ivoire in 2008 and the CO2 emissions (% of total fuel combustion) in Namibia in 2011?
Ensure brevity in your answer.  10.71. What is the difference between the CO2 emissions (% of total fuel combustion) of Croatia in 2008 and the CO2 emissions (% of total fuel combustion) of Montenegro in 2011?
Your answer should be very brief. 12.14. What is the difference between the CO2 emissions (% of total fuel combustion) of Croatia in 2008 and the CO2 emissions (% of total fuel combustion) of Namibia in 2011?
Keep it short and to the point. 12.21. What is the difference between the CO2 emissions (% of total fuel combustion) in Montenegro in 2008 and the CO2 emissions (% of total fuel combustion) in Namibia in 2011?
Ensure brevity in your answer.  1.17. What is the difference between the CO2 emissions (% of total fuel combustion) of Cote d'Ivoire in 2008 and the CO2 emissions (% of total fuel combustion) of Croatia in 2012?
Provide a short and direct response. -2.05. What is the difference between the CO2 emissions (% of total fuel combustion) of Cote d'Ivoire in 2008 and the CO2 emissions (% of total fuel combustion) of Montenegro in 2012?
Make the answer very short. 10.17. What is the difference between the CO2 emissions (% of total fuel combustion) in Cote d'Ivoire in 2008 and the CO2 emissions (% of total fuel combustion) in Namibia in 2012?
Offer a very short reply. 10.73. What is the difference between the CO2 emissions (% of total fuel combustion) of Croatia in 2008 and the CO2 emissions (% of total fuel combustion) of Montenegro in 2012?
Keep it short and to the point. 11.67. What is the difference between the CO2 emissions (% of total fuel combustion) in Croatia in 2008 and the CO2 emissions (% of total fuel combustion) in Namibia in 2012?
Provide a short and direct response. 12.23. What is the difference between the CO2 emissions (% of total fuel combustion) of Montenegro in 2008 and the CO2 emissions (% of total fuel combustion) of Namibia in 2012?
Your answer should be very brief. 1.18. What is the difference between the CO2 emissions (% of total fuel combustion) in Cote d'Ivoire in 2009 and the CO2 emissions (% of total fuel combustion) in Croatia in 2010?
Ensure brevity in your answer.  -4.93. What is the difference between the CO2 emissions (% of total fuel combustion) of Cote d'Ivoire in 2009 and the CO2 emissions (% of total fuel combustion) of Montenegro in 2010?
Your response must be concise. 9.24. What is the difference between the CO2 emissions (% of total fuel combustion) of Cote d'Ivoire in 2009 and the CO2 emissions (% of total fuel combustion) of Namibia in 2010?
Your answer should be very brief. 9.31. What is the difference between the CO2 emissions (% of total fuel combustion) in Croatia in 2009 and the CO2 emissions (% of total fuel combustion) in Montenegro in 2010?
Provide a short and direct response. 13.16. What is the difference between the CO2 emissions (% of total fuel combustion) of Croatia in 2009 and the CO2 emissions (% of total fuel combustion) of Namibia in 2010?
Give a very brief answer. 13.23. What is the difference between the CO2 emissions (% of total fuel combustion) in Montenegro in 2009 and the CO2 emissions (% of total fuel combustion) in Namibia in 2010?
Offer a terse response. 0.84. What is the difference between the CO2 emissions (% of total fuel combustion) of Cote d'Ivoire in 2009 and the CO2 emissions (% of total fuel combustion) of Croatia in 2011?
Keep it short and to the point. -3.73. What is the difference between the CO2 emissions (% of total fuel combustion) in Cote d'Ivoire in 2009 and the CO2 emissions (% of total fuel combustion) in Montenegro in 2011?
Make the answer very short. 9.24. What is the difference between the CO2 emissions (% of total fuel combustion) of Cote d'Ivoire in 2009 and the CO2 emissions (% of total fuel combustion) of Namibia in 2011?
Give a very brief answer. 9.31. What is the difference between the CO2 emissions (% of total fuel combustion) in Croatia in 2009 and the CO2 emissions (% of total fuel combustion) in Montenegro in 2011?
Offer a very short reply. 13.16. What is the difference between the CO2 emissions (% of total fuel combustion) in Croatia in 2009 and the CO2 emissions (% of total fuel combustion) in Namibia in 2011?
Make the answer very short. 13.23. What is the difference between the CO2 emissions (% of total fuel combustion) in Montenegro in 2009 and the CO2 emissions (% of total fuel combustion) in Namibia in 2011?
Provide a short and direct response. 0.84. What is the difference between the CO2 emissions (% of total fuel combustion) of Cote d'Ivoire in 2009 and the CO2 emissions (% of total fuel combustion) of Croatia in 2012?
Make the answer very short. -3.44. What is the difference between the CO2 emissions (% of total fuel combustion) of Cote d'Ivoire in 2009 and the CO2 emissions (% of total fuel combustion) of Montenegro in 2012?
Your answer should be compact. 8.78. What is the difference between the CO2 emissions (% of total fuel combustion) of Cote d'Ivoire in 2009 and the CO2 emissions (% of total fuel combustion) of Namibia in 2012?
Give a very brief answer. 9.33. What is the difference between the CO2 emissions (% of total fuel combustion) of Croatia in 2009 and the CO2 emissions (% of total fuel combustion) of Montenegro in 2012?
Your answer should be compact. 12.69. What is the difference between the CO2 emissions (% of total fuel combustion) in Croatia in 2009 and the CO2 emissions (% of total fuel combustion) in Namibia in 2012?
Offer a terse response. 13.25. What is the difference between the CO2 emissions (% of total fuel combustion) of Montenegro in 2009 and the CO2 emissions (% of total fuel combustion) of Namibia in 2012?
Your answer should be very brief. 0.86. What is the difference between the CO2 emissions (% of total fuel combustion) of Cote d'Ivoire in 2010 and the CO2 emissions (% of total fuel combustion) of Croatia in 2011?
Your response must be concise. -3.23. What is the difference between the CO2 emissions (% of total fuel combustion) in Cote d'Ivoire in 2010 and the CO2 emissions (% of total fuel combustion) in Montenegro in 2011?
Offer a very short reply. 9.74. What is the difference between the CO2 emissions (% of total fuel combustion) of Cote d'Ivoire in 2010 and the CO2 emissions (% of total fuel combustion) of Namibia in 2011?
Make the answer very short. 9.81. What is the difference between the CO2 emissions (% of total fuel combustion) in Croatia in 2010 and the CO2 emissions (% of total fuel combustion) in Montenegro in 2011?
Keep it short and to the point. 14.17. What is the difference between the CO2 emissions (% of total fuel combustion) of Croatia in 2010 and the CO2 emissions (% of total fuel combustion) of Namibia in 2011?
Make the answer very short. 14.24. What is the difference between the CO2 emissions (% of total fuel combustion) in Montenegro in 2010 and the CO2 emissions (% of total fuel combustion) in Namibia in 2011?
Offer a terse response. 0.07. What is the difference between the CO2 emissions (% of total fuel combustion) in Cote d'Ivoire in 2010 and the CO2 emissions (% of total fuel combustion) in Croatia in 2012?
Your answer should be compact. -2.94. What is the difference between the CO2 emissions (% of total fuel combustion) in Cote d'Ivoire in 2010 and the CO2 emissions (% of total fuel combustion) in Montenegro in 2012?
Ensure brevity in your answer.  9.28. What is the difference between the CO2 emissions (% of total fuel combustion) in Cote d'Ivoire in 2010 and the CO2 emissions (% of total fuel combustion) in Namibia in 2012?
Keep it short and to the point. 9.83. What is the difference between the CO2 emissions (% of total fuel combustion) in Croatia in 2010 and the CO2 emissions (% of total fuel combustion) in Montenegro in 2012?
Your answer should be very brief. 13.7. What is the difference between the CO2 emissions (% of total fuel combustion) in Croatia in 2010 and the CO2 emissions (% of total fuel combustion) in Namibia in 2012?
Ensure brevity in your answer.  14.26. What is the difference between the CO2 emissions (% of total fuel combustion) of Montenegro in 2010 and the CO2 emissions (% of total fuel combustion) of Namibia in 2012?
Your response must be concise. 0.09. What is the difference between the CO2 emissions (% of total fuel combustion) in Cote d'Ivoire in 2011 and the CO2 emissions (% of total fuel combustion) in Croatia in 2012?
Offer a very short reply. -5.38. What is the difference between the CO2 emissions (% of total fuel combustion) of Cote d'Ivoire in 2011 and the CO2 emissions (% of total fuel combustion) of Montenegro in 2012?
Keep it short and to the point. 6.84. What is the difference between the CO2 emissions (% of total fuel combustion) in Cote d'Ivoire in 2011 and the CO2 emissions (% of total fuel combustion) in Namibia in 2012?
Your response must be concise. 7.39. What is the difference between the CO2 emissions (% of total fuel combustion) of Croatia in 2011 and the CO2 emissions (% of total fuel combustion) of Montenegro in 2012?
Your response must be concise. 12.5. What is the difference between the CO2 emissions (% of total fuel combustion) of Croatia in 2011 and the CO2 emissions (% of total fuel combustion) of Namibia in 2012?
Make the answer very short. 13.06. What is the difference between the CO2 emissions (% of total fuel combustion) of Montenegro in 2011 and the CO2 emissions (% of total fuel combustion) of Namibia in 2012?
Ensure brevity in your answer.  0.09. What is the average CO2 emissions (% of total fuel combustion) in Cote d'Ivoire per year?
Make the answer very short. 9.43. What is the average CO2 emissions (% of total fuel combustion) of Croatia per year?
Provide a short and direct response. 13.47. What is the average CO2 emissions (% of total fuel combustion) in Montenegro per year?
Offer a very short reply. 0.96. What is the average CO2 emissions (% of total fuel combustion) of Namibia per year?
Your response must be concise. 0.37. In the year 2005, what is the difference between the CO2 emissions (% of total fuel combustion) of Cote d'Ivoire and CO2 emissions (% of total fuel combustion) of Croatia?
Your answer should be very brief. -5. In the year 2005, what is the difference between the CO2 emissions (% of total fuel combustion) of Cote d'Ivoire and CO2 emissions (% of total fuel combustion) of Montenegro?
Offer a terse response. 9.49. In the year 2005, what is the difference between the CO2 emissions (% of total fuel combustion) in Cote d'Ivoire and CO2 emissions (% of total fuel combustion) in Namibia?
Provide a succinct answer. 9.57. In the year 2005, what is the difference between the CO2 emissions (% of total fuel combustion) of Croatia and CO2 emissions (% of total fuel combustion) of Montenegro?
Offer a terse response. 14.49. In the year 2005, what is the difference between the CO2 emissions (% of total fuel combustion) in Croatia and CO2 emissions (% of total fuel combustion) in Namibia?
Give a very brief answer. 14.57. In the year 2005, what is the difference between the CO2 emissions (% of total fuel combustion) in Montenegro and CO2 emissions (% of total fuel combustion) in Namibia?
Provide a short and direct response. 0.08. In the year 2006, what is the difference between the CO2 emissions (% of total fuel combustion) of Cote d'Ivoire and CO2 emissions (% of total fuel combustion) of Croatia?
Give a very brief answer. -3.2. In the year 2006, what is the difference between the CO2 emissions (% of total fuel combustion) in Cote d'Ivoire and CO2 emissions (% of total fuel combustion) in Montenegro?
Give a very brief answer. 9.32. In the year 2006, what is the difference between the CO2 emissions (% of total fuel combustion) in Cote d'Ivoire and CO2 emissions (% of total fuel combustion) in Namibia?
Offer a very short reply. 10.25. In the year 2006, what is the difference between the CO2 emissions (% of total fuel combustion) in Croatia and CO2 emissions (% of total fuel combustion) in Montenegro?
Give a very brief answer. 12.52. In the year 2006, what is the difference between the CO2 emissions (% of total fuel combustion) of Croatia and CO2 emissions (% of total fuel combustion) of Namibia?
Your answer should be very brief. 13.45. In the year 2006, what is the difference between the CO2 emissions (% of total fuel combustion) in Montenegro and CO2 emissions (% of total fuel combustion) in Namibia?
Provide a succinct answer. 0.93. In the year 2007, what is the difference between the CO2 emissions (% of total fuel combustion) in Cote d'Ivoire and CO2 emissions (% of total fuel combustion) in Croatia?
Keep it short and to the point. -2.9. In the year 2007, what is the difference between the CO2 emissions (% of total fuel combustion) of Cote d'Ivoire and CO2 emissions (% of total fuel combustion) of Montenegro?
Make the answer very short. 7.4. In the year 2007, what is the difference between the CO2 emissions (% of total fuel combustion) in Cote d'Ivoire and CO2 emissions (% of total fuel combustion) in Namibia?
Keep it short and to the point. 8.43. In the year 2007, what is the difference between the CO2 emissions (% of total fuel combustion) in Croatia and CO2 emissions (% of total fuel combustion) in Montenegro?
Your answer should be very brief. 10.3. In the year 2007, what is the difference between the CO2 emissions (% of total fuel combustion) in Croatia and CO2 emissions (% of total fuel combustion) in Namibia?
Ensure brevity in your answer.  11.33. In the year 2007, what is the difference between the CO2 emissions (% of total fuel combustion) in Montenegro and CO2 emissions (% of total fuel combustion) in Namibia?
Provide a short and direct response. 1.03. In the year 2008, what is the difference between the CO2 emissions (% of total fuel combustion) of Cote d'Ivoire and CO2 emissions (% of total fuel combustion) of Croatia?
Provide a short and direct response. -1.5. In the year 2008, what is the difference between the CO2 emissions (% of total fuel combustion) of Cote d'Ivoire and CO2 emissions (% of total fuel combustion) of Montenegro?
Offer a terse response. 9.54. In the year 2008, what is the difference between the CO2 emissions (% of total fuel combustion) of Cote d'Ivoire and CO2 emissions (% of total fuel combustion) of Namibia?
Your answer should be compact. 10.68. In the year 2008, what is the difference between the CO2 emissions (% of total fuel combustion) in Croatia and CO2 emissions (% of total fuel combustion) in Montenegro?
Make the answer very short. 11.04. In the year 2008, what is the difference between the CO2 emissions (% of total fuel combustion) of Croatia and CO2 emissions (% of total fuel combustion) of Namibia?
Make the answer very short. 12.18. In the year 2008, what is the difference between the CO2 emissions (% of total fuel combustion) in Montenegro and CO2 emissions (% of total fuel combustion) in Namibia?
Provide a short and direct response. 1.14. In the year 2009, what is the difference between the CO2 emissions (% of total fuel combustion) in Cote d'Ivoire and CO2 emissions (% of total fuel combustion) in Croatia?
Provide a short and direct response. -3.92. In the year 2009, what is the difference between the CO2 emissions (% of total fuel combustion) in Cote d'Ivoire and CO2 emissions (% of total fuel combustion) in Montenegro?
Your answer should be very brief. 8.47. In the year 2009, what is the difference between the CO2 emissions (% of total fuel combustion) in Cote d'Ivoire and CO2 emissions (% of total fuel combustion) in Namibia?
Your answer should be compact. 9.29. In the year 2009, what is the difference between the CO2 emissions (% of total fuel combustion) of Croatia and CO2 emissions (% of total fuel combustion) of Montenegro?
Your answer should be very brief. 12.39. In the year 2009, what is the difference between the CO2 emissions (% of total fuel combustion) in Croatia and CO2 emissions (% of total fuel combustion) in Namibia?
Keep it short and to the point. 13.21. In the year 2009, what is the difference between the CO2 emissions (% of total fuel combustion) of Montenegro and CO2 emissions (% of total fuel combustion) of Namibia?
Make the answer very short. 0.83. In the year 2010, what is the difference between the CO2 emissions (% of total fuel combustion) of Cote d'Ivoire and CO2 emissions (% of total fuel combustion) of Croatia?
Give a very brief answer. -4.43. In the year 2010, what is the difference between the CO2 emissions (% of total fuel combustion) of Cote d'Ivoire and CO2 emissions (% of total fuel combustion) of Montenegro?
Your response must be concise. 9.74. In the year 2010, what is the difference between the CO2 emissions (% of total fuel combustion) of Cote d'Ivoire and CO2 emissions (% of total fuel combustion) of Namibia?
Give a very brief answer. 9.81. In the year 2010, what is the difference between the CO2 emissions (% of total fuel combustion) in Croatia and CO2 emissions (% of total fuel combustion) in Montenegro?
Offer a terse response. 14.17. In the year 2010, what is the difference between the CO2 emissions (% of total fuel combustion) in Croatia and CO2 emissions (% of total fuel combustion) in Namibia?
Provide a succinct answer. 14.24. In the year 2010, what is the difference between the CO2 emissions (% of total fuel combustion) of Montenegro and CO2 emissions (% of total fuel combustion) of Namibia?
Ensure brevity in your answer.  0.07. In the year 2011, what is the difference between the CO2 emissions (% of total fuel combustion) of Cote d'Ivoire and CO2 emissions (% of total fuel combustion) of Croatia?
Keep it short and to the point. -5.67. In the year 2011, what is the difference between the CO2 emissions (% of total fuel combustion) of Cote d'Ivoire and CO2 emissions (% of total fuel combustion) of Montenegro?
Keep it short and to the point. 7.31. In the year 2011, what is the difference between the CO2 emissions (% of total fuel combustion) in Cote d'Ivoire and CO2 emissions (% of total fuel combustion) in Namibia?
Keep it short and to the point. 7.37. In the year 2011, what is the difference between the CO2 emissions (% of total fuel combustion) in Croatia and CO2 emissions (% of total fuel combustion) in Montenegro?
Keep it short and to the point. 12.97. In the year 2011, what is the difference between the CO2 emissions (% of total fuel combustion) in Croatia and CO2 emissions (% of total fuel combustion) in Namibia?
Provide a short and direct response. 13.04. In the year 2011, what is the difference between the CO2 emissions (% of total fuel combustion) of Montenegro and CO2 emissions (% of total fuel combustion) of Namibia?
Your response must be concise. 0.07. In the year 2012, what is the difference between the CO2 emissions (% of total fuel combustion) in Cote d'Ivoire and CO2 emissions (% of total fuel combustion) in Croatia?
Offer a very short reply. -5.68. In the year 2012, what is the difference between the CO2 emissions (% of total fuel combustion) in Cote d'Ivoire and CO2 emissions (% of total fuel combustion) in Montenegro?
Make the answer very short. 6.54. In the year 2012, what is the difference between the CO2 emissions (% of total fuel combustion) in Cote d'Ivoire and CO2 emissions (% of total fuel combustion) in Namibia?
Your response must be concise. 7.09. In the year 2012, what is the difference between the CO2 emissions (% of total fuel combustion) of Croatia and CO2 emissions (% of total fuel combustion) of Montenegro?
Offer a terse response. 12.22. In the year 2012, what is the difference between the CO2 emissions (% of total fuel combustion) in Croatia and CO2 emissions (% of total fuel combustion) in Namibia?
Your answer should be compact. 12.77. In the year 2012, what is the difference between the CO2 emissions (% of total fuel combustion) of Montenegro and CO2 emissions (% of total fuel combustion) of Namibia?
Make the answer very short. 0.56. What is the ratio of the CO2 emissions (% of total fuel combustion) in Cote d'Ivoire in 2005 to that in 2006?
Offer a very short reply. 0.94. What is the ratio of the CO2 emissions (% of total fuel combustion) in Croatia in 2005 to that in 2006?
Offer a very short reply. 1.08. What is the ratio of the CO2 emissions (% of total fuel combustion) of Montenegro in 2005 to that in 2006?
Keep it short and to the point. 0.38. What is the ratio of the CO2 emissions (% of total fuel combustion) in Namibia in 2005 to that in 2006?
Offer a very short reply. 1.01. What is the ratio of the CO2 emissions (% of total fuel combustion) of Cote d'Ivoire in 2005 to that in 2007?
Provide a succinct answer. 1.13. What is the ratio of the CO2 emissions (% of total fuel combustion) of Croatia in 2005 to that in 2007?
Offer a terse response. 1.28. What is the ratio of the CO2 emissions (% of total fuel combustion) in Montenegro in 2005 to that in 2007?
Make the answer very short. 0.36. What is the ratio of the CO2 emissions (% of total fuel combustion) in Namibia in 2005 to that in 2007?
Make the answer very short. 1.04. What is the ratio of the CO2 emissions (% of total fuel combustion) in Cote d'Ivoire in 2005 to that in 2008?
Provide a succinct answer. 0.91. What is the ratio of the CO2 emissions (% of total fuel combustion) in Croatia in 2005 to that in 2008?
Ensure brevity in your answer.  1.2. What is the ratio of the CO2 emissions (% of total fuel combustion) of Montenegro in 2005 to that in 2008?
Your answer should be very brief. 0.34. What is the ratio of the CO2 emissions (% of total fuel combustion) in Namibia in 2005 to that in 2008?
Offer a terse response. 1.2. What is the ratio of the CO2 emissions (% of total fuel combustion) of Cote d'Ivoire in 2005 to that in 2009?
Offer a terse response. 1.04. What is the ratio of the CO2 emissions (% of total fuel combustion) of Croatia in 2005 to that in 2009?
Give a very brief answer. 1.11. What is the ratio of the CO2 emissions (% of total fuel combustion) of Montenegro in 2005 to that in 2009?
Offer a terse response. 0.44. What is the ratio of the CO2 emissions (% of total fuel combustion) in Namibia in 2005 to that in 2009?
Your answer should be very brief. 1.23. What is the ratio of the CO2 emissions (% of total fuel combustion) in Cote d'Ivoire in 2005 to that in 2010?
Make the answer very short. 0.99. What is the ratio of the CO2 emissions (% of total fuel combustion) of Croatia in 2005 to that in 2010?
Provide a short and direct response. 1.03. What is the ratio of the CO2 emissions (% of total fuel combustion) of Montenegro in 2005 to that in 2010?
Ensure brevity in your answer.  1.27. What is the ratio of the CO2 emissions (% of total fuel combustion) in Namibia in 2005 to that in 2010?
Offer a very short reply. 1.28. What is the ratio of the CO2 emissions (% of total fuel combustion) in Cote d'Ivoire in 2005 to that in 2011?
Your response must be concise. 1.3. What is the ratio of the CO2 emissions (% of total fuel combustion) in Croatia in 2005 to that in 2011?
Offer a terse response. 1.12. What is the ratio of the CO2 emissions (% of total fuel combustion) in Montenegro in 2005 to that in 2011?
Provide a succinct answer. 1.28. What is the ratio of the CO2 emissions (% of total fuel combustion) of Namibia in 2005 to that in 2011?
Offer a very short reply. 1.29. What is the ratio of the CO2 emissions (% of total fuel combustion) in Cote d'Ivoire in 2005 to that in 2012?
Your answer should be very brief. 1.35. What is the ratio of the CO2 emissions (% of total fuel combustion) of Croatia in 2005 to that in 2012?
Offer a very short reply. 1.15. What is the ratio of the CO2 emissions (% of total fuel combustion) in Montenegro in 2005 to that in 2012?
Your response must be concise. 0.59. What is the ratio of the CO2 emissions (% of total fuel combustion) in Namibia in 2005 to that in 2012?
Make the answer very short. 1.36. What is the ratio of the CO2 emissions (% of total fuel combustion) of Cote d'Ivoire in 2006 to that in 2007?
Keep it short and to the point. 1.21. What is the ratio of the CO2 emissions (% of total fuel combustion) of Croatia in 2006 to that in 2007?
Your answer should be compact. 1.18. What is the ratio of the CO2 emissions (% of total fuel combustion) in Montenegro in 2006 to that in 2007?
Provide a short and direct response. 0.94. What is the ratio of the CO2 emissions (% of total fuel combustion) of Namibia in 2006 to that in 2007?
Offer a very short reply. 1.03. What is the ratio of the CO2 emissions (% of total fuel combustion) in Cote d'Ivoire in 2006 to that in 2008?
Provide a short and direct response. 0.97. What is the ratio of the CO2 emissions (% of total fuel combustion) of Croatia in 2006 to that in 2008?
Ensure brevity in your answer.  1.11. What is the ratio of the CO2 emissions (% of total fuel combustion) in Montenegro in 2006 to that in 2008?
Your response must be concise. 0.9. What is the ratio of the CO2 emissions (% of total fuel combustion) in Namibia in 2006 to that in 2008?
Your answer should be very brief. 1.19. What is the ratio of the CO2 emissions (% of total fuel combustion) of Cote d'Ivoire in 2006 to that in 2009?
Your answer should be compact. 1.11. What is the ratio of the CO2 emissions (% of total fuel combustion) of Croatia in 2006 to that in 2009?
Keep it short and to the point. 1.02. What is the ratio of the CO2 emissions (% of total fuel combustion) in Montenegro in 2006 to that in 2009?
Your answer should be very brief. 1.15. What is the ratio of the CO2 emissions (% of total fuel combustion) in Namibia in 2006 to that in 2009?
Offer a very short reply. 1.22. What is the ratio of the CO2 emissions (% of total fuel combustion) of Cote d'Ivoire in 2006 to that in 2010?
Ensure brevity in your answer.  1.05. What is the ratio of the CO2 emissions (% of total fuel combustion) of Croatia in 2006 to that in 2010?
Your answer should be very brief. 0.95. What is the ratio of the CO2 emissions (% of total fuel combustion) of Montenegro in 2006 to that in 2010?
Your response must be concise. 3.35. What is the ratio of the CO2 emissions (% of total fuel combustion) of Namibia in 2006 to that in 2010?
Offer a terse response. 1.27. What is the ratio of the CO2 emissions (% of total fuel combustion) in Cote d'Ivoire in 2006 to that in 2011?
Offer a very short reply. 1.39. What is the ratio of the CO2 emissions (% of total fuel combustion) in Croatia in 2006 to that in 2011?
Offer a very short reply. 1.04. What is the ratio of the CO2 emissions (% of total fuel combustion) in Montenegro in 2006 to that in 2011?
Provide a succinct answer. 3.38. What is the ratio of the CO2 emissions (% of total fuel combustion) in Namibia in 2006 to that in 2011?
Give a very brief answer. 1.28. What is the ratio of the CO2 emissions (% of total fuel combustion) in Cote d'Ivoire in 2006 to that in 2012?
Make the answer very short. 1.44. What is the ratio of the CO2 emissions (% of total fuel combustion) of Croatia in 2006 to that in 2012?
Provide a short and direct response. 1.06. What is the ratio of the CO2 emissions (% of total fuel combustion) of Montenegro in 2006 to that in 2012?
Ensure brevity in your answer.  1.55. What is the ratio of the CO2 emissions (% of total fuel combustion) of Namibia in 2006 to that in 2012?
Your answer should be compact. 1.35. What is the ratio of the CO2 emissions (% of total fuel combustion) of Cote d'Ivoire in 2007 to that in 2008?
Your answer should be very brief. 0.8. What is the ratio of the CO2 emissions (% of total fuel combustion) of Croatia in 2007 to that in 2008?
Provide a short and direct response. 0.94. What is the ratio of the CO2 emissions (% of total fuel combustion) of Montenegro in 2007 to that in 2008?
Your answer should be compact. 0.96. What is the ratio of the CO2 emissions (% of total fuel combustion) of Namibia in 2007 to that in 2008?
Make the answer very short. 1.15. What is the ratio of the CO2 emissions (% of total fuel combustion) in Cote d'Ivoire in 2007 to that in 2009?
Keep it short and to the point. 0.92. What is the ratio of the CO2 emissions (% of total fuel combustion) in Croatia in 2007 to that in 2009?
Offer a terse response. 0.87. What is the ratio of the CO2 emissions (% of total fuel combustion) of Montenegro in 2007 to that in 2009?
Make the answer very short. 1.23. What is the ratio of the CO2 emissions (% of total fuel combustion) in Namibia in 2007 to that in 2009?
Offer a terse response. 1.18. What is the ratio of the CO2 emissions (% of total fuel combustion) in Cote d'Ivoire in 2007 to that in 2010?
Ensure brevity in your answer.  0.87. What is the ratio of the CO2 emissions (% of total fuel combustion) of Croatia in 2007 to that in 2010?
Your answer should be very brief. 0.81. What is the ratio of the CO2 emissions (% of total fuel combustion) in Montenegro in 2007 to that in 2010?
Provide a short and direct response. 3.58. What is the ratio of the CO2 emissions (% of total fuel combustion) in Namibia in 2007 to that in 2010?
Provide a short and direct response. 1.23. What is the ratio of the CO2 emissions (% of total fuel combustion) of Cote d'Ivoire in 2007 to that in 2011?
Ensure brevity in your answer.  1.15. What is the ratio of the CO2 emissions (% of total fuel combustion) in Croatia in 2007 to that in 2011?
Provide a succinct answer. 0.88. What is the ratio of the CO2 emissions (% of total fuel combustion) of Montenegro in 2007 to that in 2011?
Keep it short and to the point. 3.61. What is the ratio of the CO2 emissions (% of total fuel combustion) of Namibia in 2007 to that in 2011?
Offer a terse response. 1.24. What is the ratio of the CO2 emissions (% of total fuel combustion) in Cote d'Ivoire in 2007 to that in 2012?
Make the answer very short. 1.19. What is the ratio of the CO2 emissions (% of total fuel combustion) in Croatia in 2007 to that in 2012?
Make the answer very short. 0.9. What is the ratio of the CO2 emissions (% of total fuel combustion) of Montenegro in 2007 to that in 2012?
Keep it short and to the point. 1.66. What is the ratio of the CO2 emissions (% of total fuel combustion) of Namibia in 2007 to that in 2012?
Your answer should be very brief. 1.31. What is the ratio of the CO2 emissions (% of total fuel combustion) in Cote d'Ivoire in 2008 to that in 2009?
Your answer should be very brief. 1.14. What is the ratio of the CO2 emissions (% of total fuel combustion) in Croatia in 2008 to that in 2009?
Offer a terse response. 0.92. What is the ratio of the CO2 emissions (% of total fuel combustion) of Montenegro in 2008 to that in 2009?
Provide a succinct answer. 1.27. What is the ratio of the CO2 emissions (% of total fuel combustion) in Namibia in 2008 to that in 2009?
Keep it short and to the point. 1.03. What is the ratio of the CO2 emissions (% of total fuel combustion) in Cote d'Ivoire in 2008 to that in 2010?
Your answer should be compact. 1.09. What is the ratio of the CO2 emissions (% of total fuel combustion) in Croatia in 2008 to that in 2010?
Provide a short and direct response. 0.86. What is the ratio of the CO2 emissions (% of total fuel combustion) of Montenegro in 2008 to that in 2010?
Ensure brevity in your answer.  3.72. What is the ratio of the CO2 emissions (% of total fuel combustion) in Namibia in 2008 to that in 2010?
Keep it short and to the point. 1.07. What is the ratio of the CO2 emissions (% of total fuel combustion) in Cote d'Ivoire in 2008 to that in 2011?
Your answer should be compact. 1.43. What is the ratio of the CO2 emissions (% of total fuel combustion) in Croatia in 2008 to that in 2011?
Keep it short and to the point. 0.94. What is the ratio of the CO2 emissions (% of total fuel combustion) in Montenegro in 2008 to that in 2011?
Give a very brief answer. 3.75. What is the ratio of the CO2 emissions (% of total fuel combustion) of Namibia in 2008 to that in 2011?
Offer a very short reply. 1.08. What is the ratio of the CO2 emissions (% of total fuel combustion) in Cote d'Ivoire in 2008 to that in 2012?
Provide a short and direct response. 1.49. What is the ratio of the CO2 emissions (% of total fuel combustion) in Croatia in 2008 to that in 2012?
Your answer should be compact. 0.96. What is the ratio of the CO2 emissions (% of total fuel combustion) in Montenegro in 2008 to that in 2012?
Offer a terse response. 1.72. What is the ratio of the CO2 emissions (% of total fuel combustion) in Namibia in 2008 to that in 2012?
Keep it short and to the point. 1.14. What is the ratio of the CO2 emissions (% of total fuel combustion) in Cote d'Ivoire in 2009 to that in 2010?
Give a very brief answer. 0.95. What is the ratio of the CO2 emissions (% of total fuel combustion) in Croatia in 2009 to that in 2010?
Your response must be concise. 0.93. What is the ratio of the CO2 emissions (% of total fuel combustion) in Montenegro in 2009 to that in 2010?
Give a very brief answer. 2.92. What is the ratio of the CO2 emissions (% of total fuel combustion) of Namibia in 2009 to that in 2010?
Ensure brevity in your answer.  1.05. What is the ratio of the CO2 emissions (% of total fuel combustion) in Cote d'Ivoire in 2009 to that in 2011?
Offer a terse response. 1.25. What is the ratio of the CO2 emissions (% of total fuel combustion) in Croatia in 2009 to that in 2011?
Make the answer very short. 1.01. What is the ratio of the CO2 emissions (% of total fuel combustion) in Montenegro in 2009 to that in 2011?
Offer a terse response. 2.94. What is the ratio of the CO2 emissions (% of total fuel combustion) in Namibia in 2009 to that in 2011?
Provide a succinct answer. 1.05. What is the ratio of the CO2 emissions (% of total fuel combustion) in Cote d'Ivoire in 2009 to that in 2012?
Provide a succinct answer. 1.3. What is the ratio of the CO2 emissions (% of total fuel combustion) of Croatia in 2009 to that in 2012?
Offer a very short reply. 1.04. What is the ratio of the CO2 emissions (% of total fuel combustion) of Montenegro in 2009 to that in 2012?
Provide a succinct answer. 1.35. What is the ratio of the CO2 emissions (% of total fuel combustion) in Namibia in 2009 to that in 2012?
Your response must be concise. 1.11. What is the ratio of the CO2 emissions (% of total fuel combustion) of Cote d'Ivoire in 2010 to that in 2011?
Keep it short and to the point. 1.32. What is the ratio of the CO2 emissions (% of total fuel combustion) of Croatia in 2010 to that in 2011?
Make the answer very short. 1.09. What is the ratio of the CO2 emissions (% of total fuel combustion) in Montenegro in 2010 to that in 2011?
Offer a very short reply. 1.01. What is the ratio of the CO2 emissions (% of total fuel combustion) of Cote d'Ivoire in 2010 to that in 2012?
Your answer should be very brief. 1.37. What is the ratio of the CO2 emissions (% of total fuel combustion) of Croatia in 2010 to that in 2012?
Offer a very short reply. 1.11. What is the ratio of the CO2 emissions (% of total fuel combustion) of Montenegro in 2010 to that in 2012?
Ensure brevity in your answer.  0.46. What is the ratio of the CO2 emissions (% of total fuel combustion) in Namibia in 2010 to that in 2012?
Offer a terse response. 1.06. What is the ratio of the CO2 emissions (% of total fuel combustion) in Cote d'Ivoire in 2011 to that in 2012?
Ensure brevity in your answer.  1.04. What is the ratio of the CO2 emissions (% of total fuel combustion) in Croatia in 2011 to that in 2012?
Make the answer very short. 1.02. What is the ratio of the CO2 emissions (% of total fuel combustion) in Montenegro in 2011 to that in 2012?
Make the answer very short. 0.46. What is the ratio of the CO2 emissions (% of total fuel combustion) in Namibia in 2011 to that in 2012?
Give a very brief answer. 1.06. What is the difference between the highest and the second highest CO2 emissions (% of total fuel combustion) of Cote d'Ivoire?
Your answer should be compact. 0.36. What is the difference between the highest and the second highest CO2 emissions (% of total fuel combustion) of Croatia?
Your response must be concise. 0.43. What is the difference between the highest and the second highest CO2 emissions (% of total fuel combustion) of Montenegro?
Make the answer very short. 0.06. What is the difference between the highest and the second highest CO2 emissions (% of total fuel combustion) in Namibia?
Your response must be concise. 0. What is the difference between the highest and the lowest CO2 emissions (% of total fuel combustion) in Cote d'Ivoire?
Make the answer very short. 3.63. What is the difference between the highest and the lowest CO2 emissions (% of total fuel combustion) in Croatia?
Provide a short and direct response. 3.26. What is the difference between the highest and the lowest CO2 emissions (% of total fuel combustion) of Montenegro?
Provide a short and direct response. 1.1. What is the difference between the highest and the lowest CO2 emissions (% of total fuel combustion) in Namibia?
Keep it short and to the point. 0.11. 